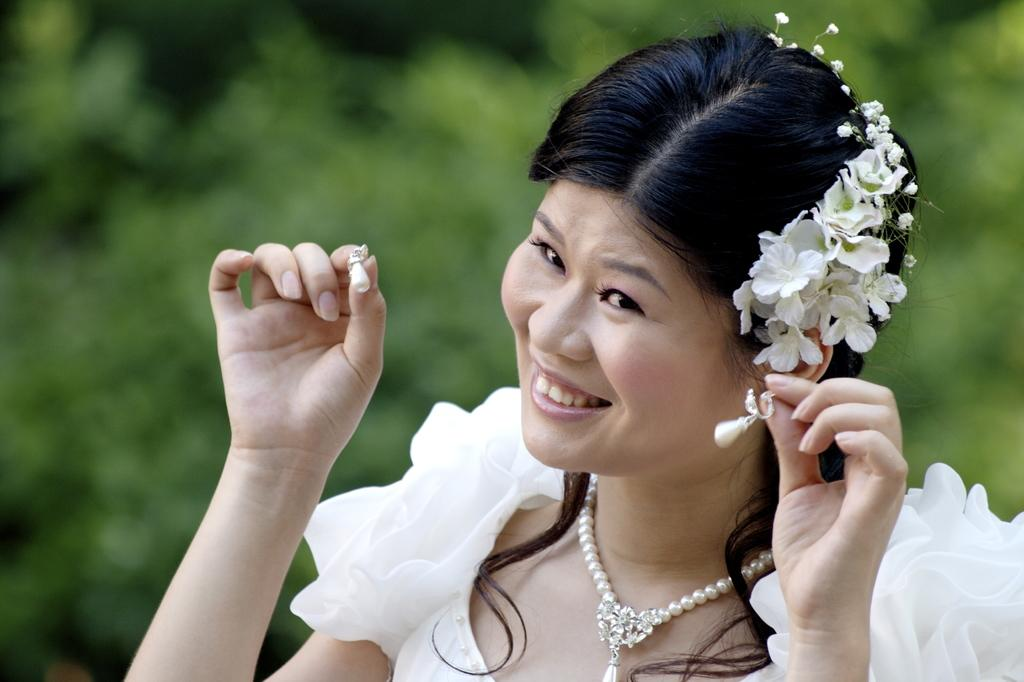What is the main subject in the foreground of the image? There is a woman in the foreground of the image. What is the woman doing in the image? The woman is smiling. What can be seen in the background of the image? There are trees in the background of the image. What type of baseball equipment can be seen in the image? There is no baseball equipment present in the image. What value does the blade have in the image? There is no blade present in the image, so it does not have any value. 